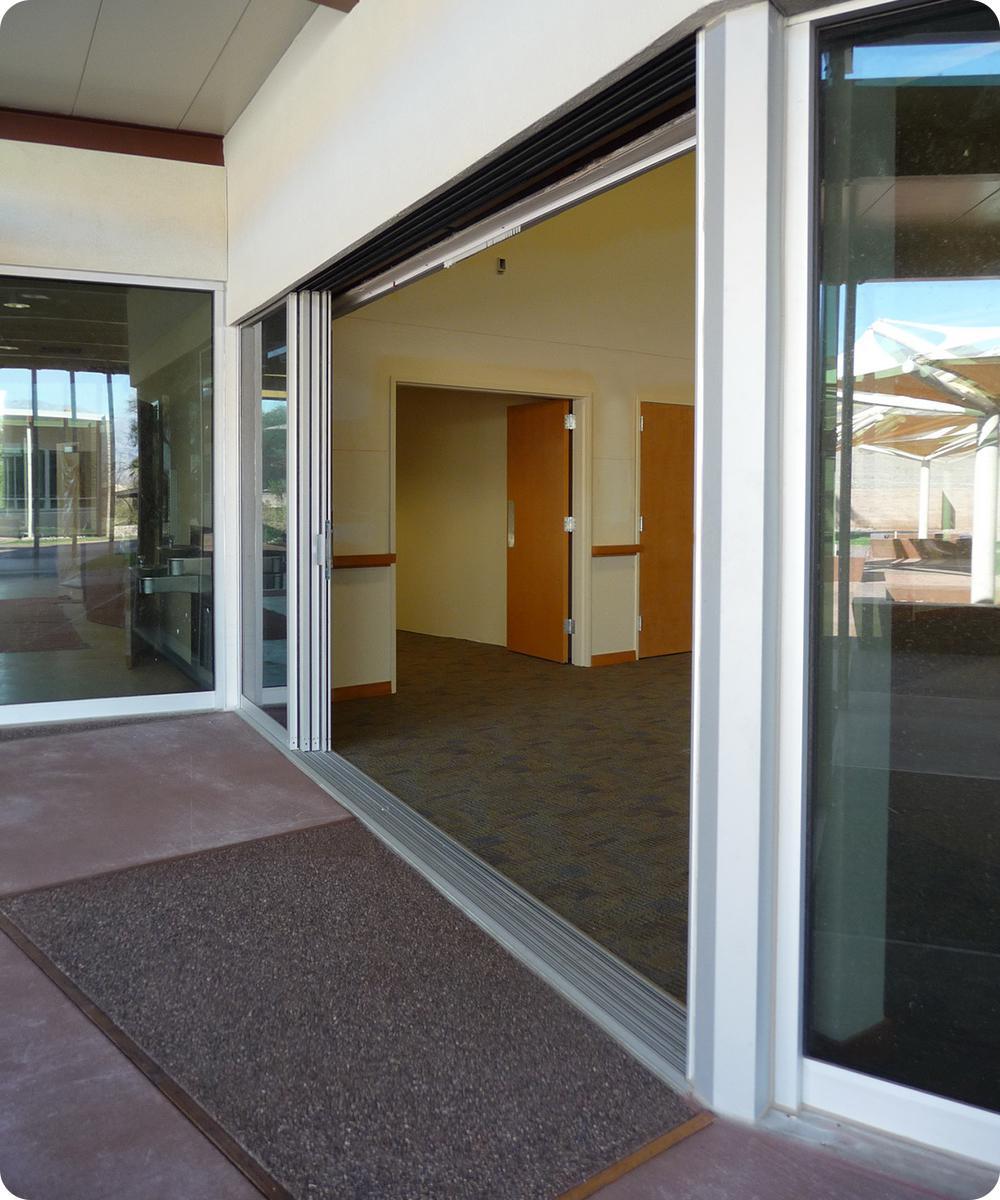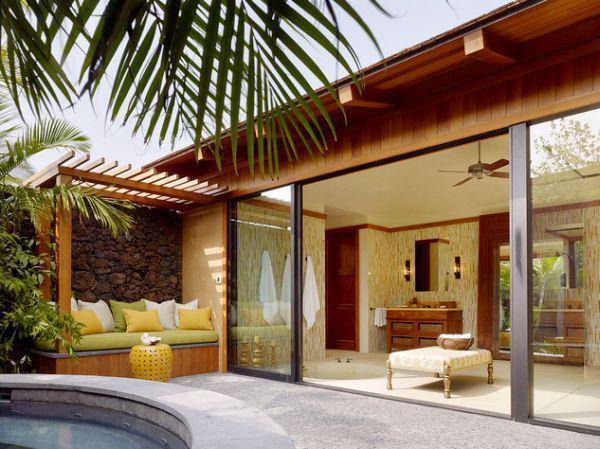The first image is the image on the left, the second image is the image on the right. Considering the images on both sides, is "In at least image there are six chairs surrounding a square table on the patio." valid? Answer yes or no. No. The first image is the image on the left, the second image is the image on the right. Analyze the images presented: Is the assertion "The right image is an exterior view of a wall of sliding glass doors, with stone-type surface in front, that face the camera and reveal a spacious furnished interior." valid? Answer yes or no. Yes. 